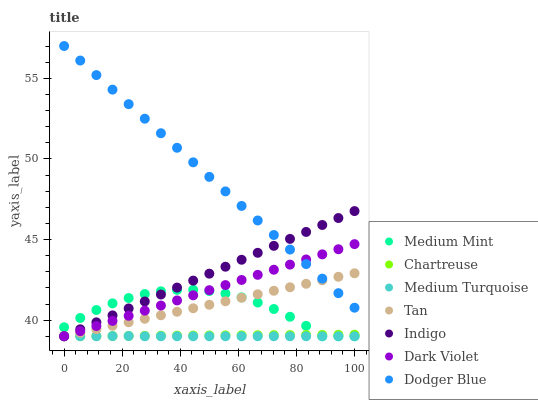Does Medium Turquoise have the minimum area under the curve?
Answer yes or no. Yes. Does Dodger Blue have the maximum area under the curve?
Answer yes or no. Yes. Does Indigo have the minimum area under the curve?
Answer yes or no. No. Does Indigo have the maximum area under the curve?
Answer yes or no. No. Is Tan the smoothest?
Answer yes or no. Yes. Is Medium Mint the roughest?
Answer yes or no. Yes. Is Indigo the smoothest?
Answer yes or no. No. Is Indigo the roughest?
Answer yes or no. No. Does Medium Mint have the lowest value?
Answer yes or no. Yes. Does Dodger Blue have the lowest value?
Answer yes or no. No. Does Dodger Blue have the highest value?
Answer yes or no. Yes. Does Indigo have the highest value?
Answer yes or no. No. Is Medium Turquoise less than Dodger Blue?
Answer yes or no. Yes. Is Dodger Blue greater than Medium Turquoise?
Answer yes or no. Yes. Does Tan intersect Indigo?
Answer yes or no. Yes. Is Tan less than Indigo?
Answer yes or no. No. Is Tan greater than Indigo?
Answer yes or no. No. Does Medium Turquoise intersect Dodger Blue?
Answer yes or no. No. 